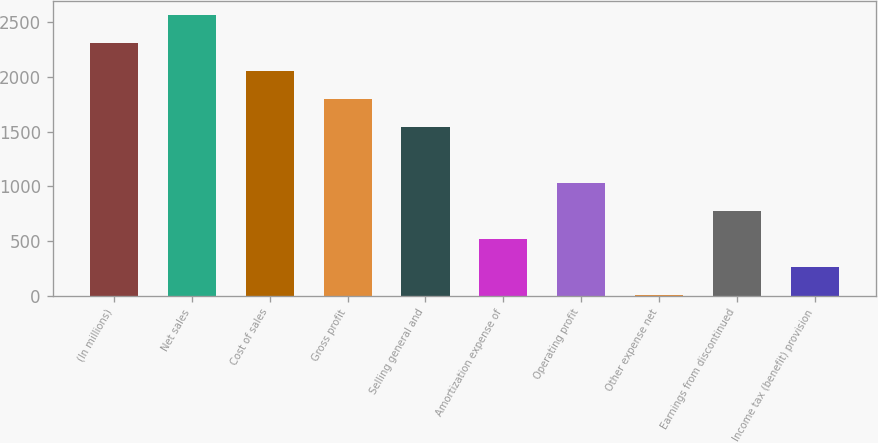Convert chart to OTSL. <chart><loc_0><loc_0><loc_500><loc_500><bar_chart><fcel>(In millions)<fcel>Net sales<fcel>Cost of sales<fcel>Gross profit<fcel>Selling general and<fcel>Amortization expense of<fcel>Operating profit<fcel>Other expense net<fcel>Earnings from discontinued<fcel>Income tax (benefit) provision<nl><fcel>2311.27<fcel>2567<fcel>2055.54<fcel>1799.81<fcel>1544.08<fcel>521.16<fcel>1032.62<fcel>9.7<fcel>776.89<fcel>265.43<nl></chart> 